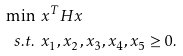Convert formula to latex. <formula><loc_0><loc_0><loc_500><loc_500>\min & \, \ x ^ { T } H x \\ s . t . & \, \ x _ { 1 } , x _ { 2 } , x _ { 3 } , x _ { 4 } , x _ { 5 } \geq 0 .</formula> 